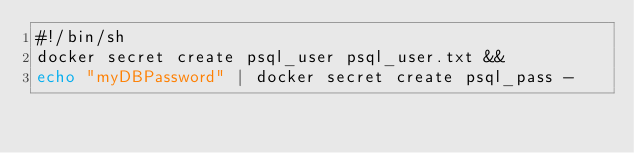Convert code to text. <code><loc_0><loc_0><loc_500><loc_500><_Bash_>#!/bin/sh
docker secret create psql_user psql_user.txt &&
echo "myDBPassword" | docker secret create psql_pass -

</code> 